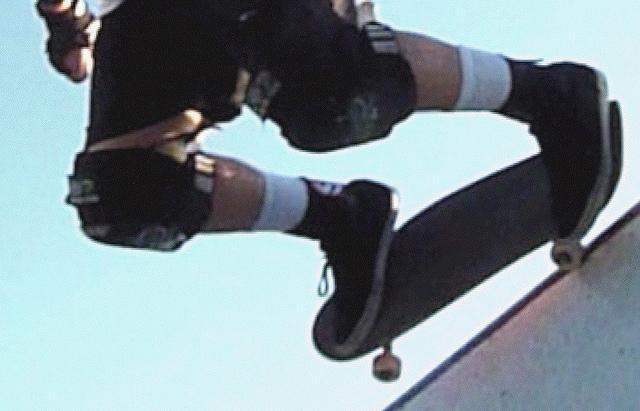How many people are on skateboards?
Give a very brief answer. 1. 